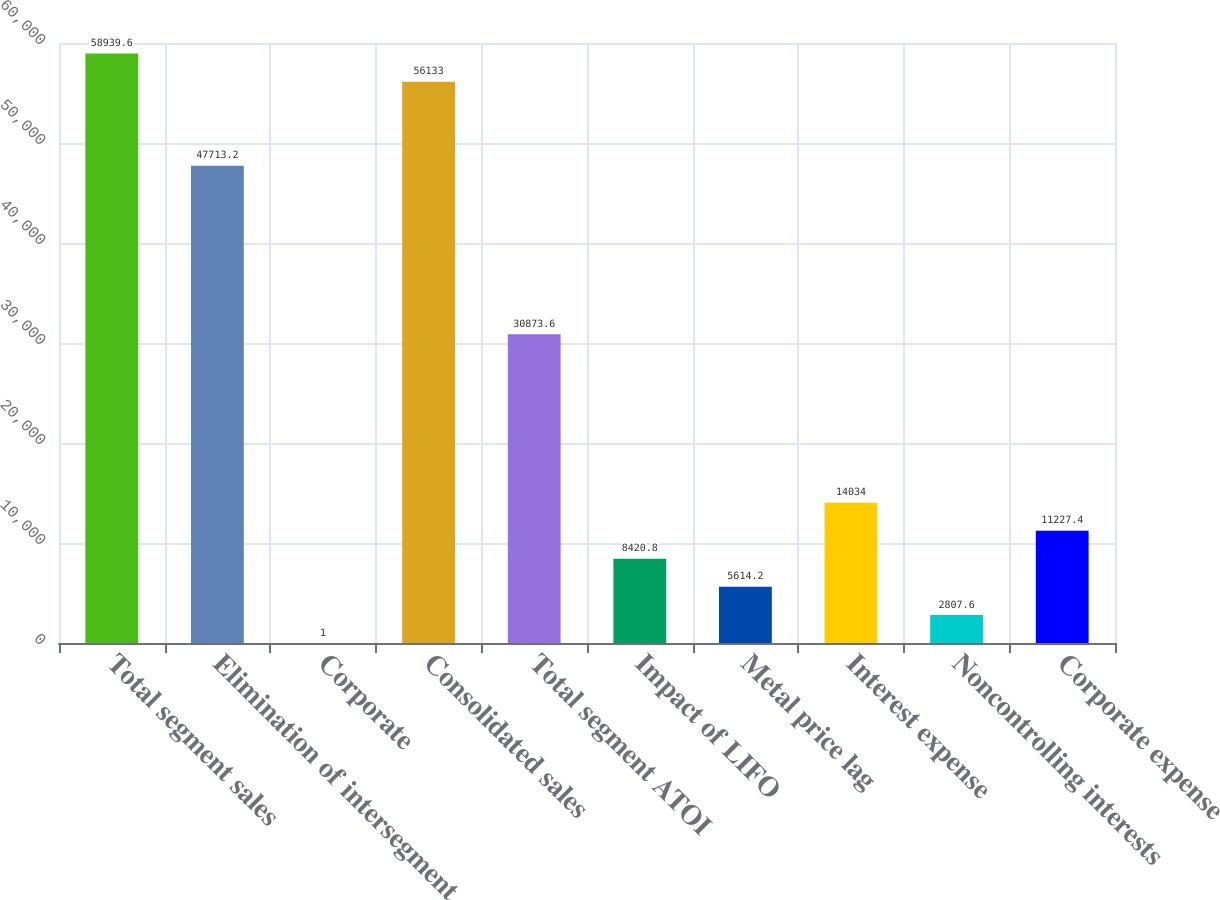<chart> <loc_0><loc_0><loc_500><loc_500><bar_chart><fcel>Total segment sales<fcel>Elimination of intersegment<fcel>Corporate<fcel>Consolidated sales<fcel>Total segment ATOI<fcel>Impact of LIFO<fcel>Metal price lag<fcel>Interest expense<fcel>Noncontrolling interests<fcel>Corporate expense<nl><fcel>58939.6<fcel>47713.2<fcel>1<fcel>56133<fcel>30873.6<fcel>8420.8<fcel>5614.2<fcel>14034<fcel>2807.6<fcel>11227.4<nl></chart> 